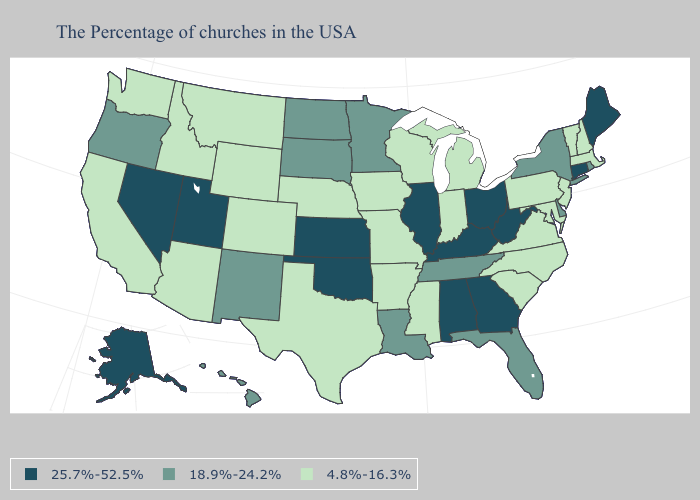What is the value of Florida?
Short answer required. 18.9%-24.2%. Name the states that have a value in the range 25.7%-52.5%?
Concise answer only. Maine, Connecticut, West Virginia, Ohio, Georgia, Kentucky, Alabama, Illinois, Kansas, Oklahoma, Utah, Nevada, Alaska. Among the states that border Oklahoma , which have the highest value?
Write a very short answer. Kansas. Which states have the highest value in the USA?
Write a very short answer. Maine, Connecticut, West Virginia, Ohio, Georgia, Kentucky, Alabama, Illinois, Kansas, Oklahoma, Utah, Nevada, Alaska. Name the states that have a value in the range 18.9%-24.2%?
Answer briefly. Rhode Island, New York, Delaware, Florida, Tennessee, Louisiana, Minnesota, South Dakota, North Dakota, New Mexico, Oregon, Hawaii. What is the value of Oklahoma?
Concise answer only. 25.7%-52.5%. Name the states that have a value in the range 18.9%-24.2%?
Concise answer only. Rhode Island, New York, Delaware, Florida, Tennessee, Louisiana, Minnesota, South Dakota, North Dakota, New Mexico, Oregon, Hawaii. What is the highest value in states that border Virginia?
Concise answer only. 25.7%-52.5%. What is the lowest value in the USA?
Write a very short answer. 4.8%-16.3%. Does Iowa have the lowest value in the USA?
Keep it brief. Yes. What is the lowest value in the USA?
Write a very short answer. 4.8%-16.3%. Among the states that border Tennessee , does Kentucky have the lowest value?
Keep it brief. No. Which states have the highest value in the USA?
Give a very brief answer. Maine, Connecticut, West Virginia, Ohio, Georgia, Kentucky, Alabama, Illinois, Kansas, Oklahoma, Utah, Nevada, Alaska. Name the states that have a value in the range 25.7%-52.5%?
Short answer required. Maine, Connecticut, West Virginia, Ohio, Georgia, Kentucky, Alabama, Illinois, Kansas, Oklahoma, Utah, Nevada, Alaska. 